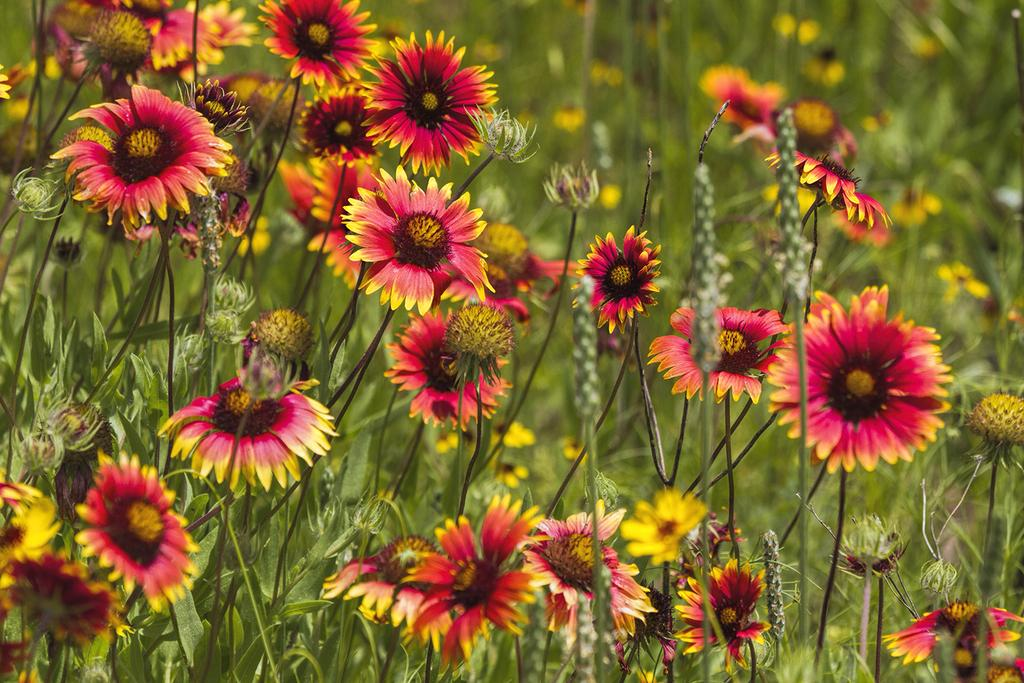What types of plants are visible in the foreground of the image? There are flowers and plants in the foreground of the image. Can you describe the arrangement of the plants in the image? The flowers and plants are in the foreground, but no specific arrangement is mentioned in the facts. Where is the throne located in the image? There is no throne present in the image. What type of string is used to tie the flowers together in the image? There is no string used to tie the flowers together in the image; they are not depicted as being tied. 